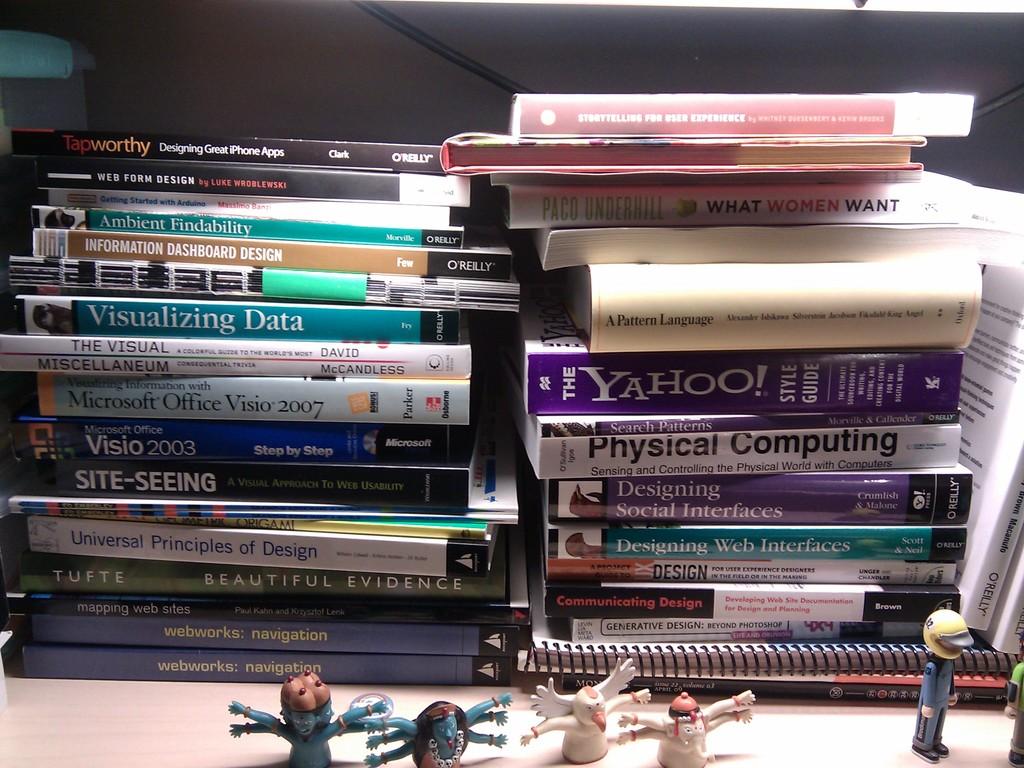What is the brand on the purple book in the right stack?
Provide a short and direct response. Yahoo. Is there a book for physical computing?
Your response must be concise. Yes. 